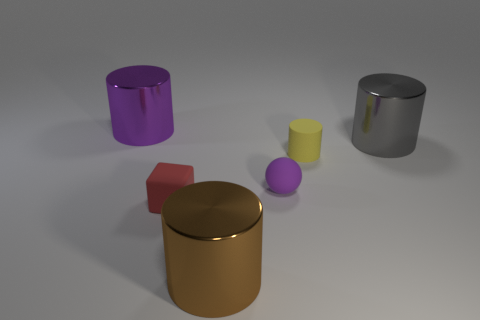Subtract 1 cylinders. How many cylinders are left? 3 Add 3 blocks. How many objects exist? 9 Subtract all cylinders. How many objects are left? 2 Add 3 tiny red rubber objects. How many tiny red rubber objects exist? 4 Subtract 0 yellow balls. How many objects are left? 6 Subtract all yellow objects. Subtract all gray objects. How many objects are left? 4 Add 4 small yellow cylinders. How many small yellow cylinders are left? 5 